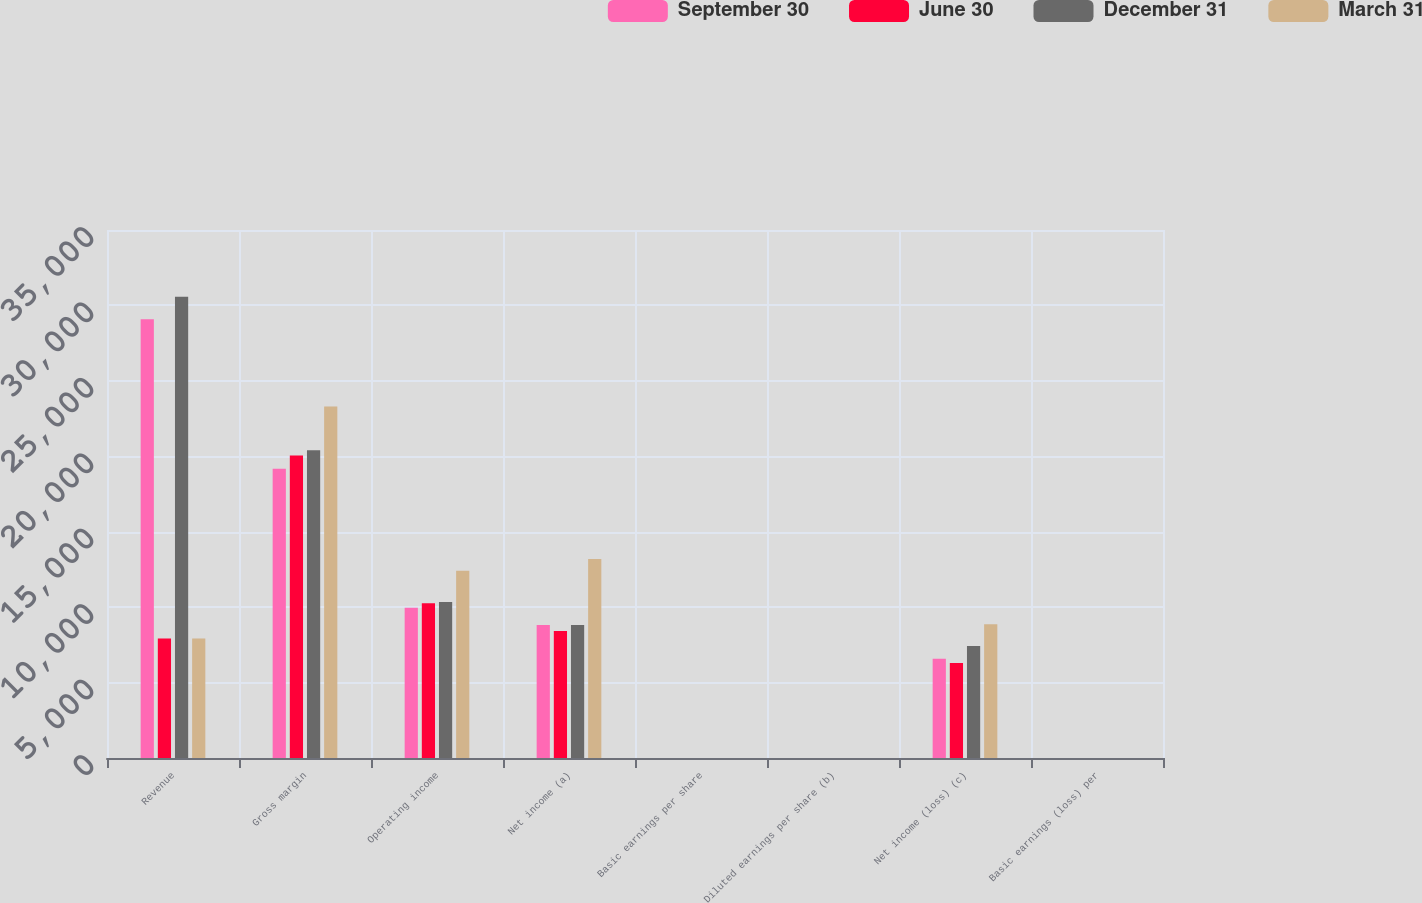Convert chart to OTSL. <chart><loc_0><loc_0><loc_500><loc_500><stacked_bar_chart><ecel><fcel>Revenue<fcel>Gross margin<fcel>Operating income<fcel>Net income (a)<fcel>Basic earnings per share<fcel>Diluted earnings per share (b)<fcel>Net income (loss) (c)<fcel>Basic earnings (loss) per<nl><fcel>September 30<fcel>29084<fcel>19179<fcel>9955<fcel>8824<fcel>1.15<fcel>1.14<fcel>6576<fcel>0.85<nl><fcel>June 30<fcel>7922<fcel>20048<fcel>10258<fcel>8420<fcel>1.09<fcel>1.08<fcel>6302<fcel>0.82<nl><fcel>December 31<fcel>30571<fcel>20401<fcel>10341<fcel>8809<fcel>1.15<fcel>1.14<fcel>7424<fcel>0.96<nl><fcel>March 31<fcel>7922<fcel>23305<fcel>12405<fcel>13187<fcel>1.72<fcel>1.71<fcel>8873<fcel>1.15<nl></chart> 